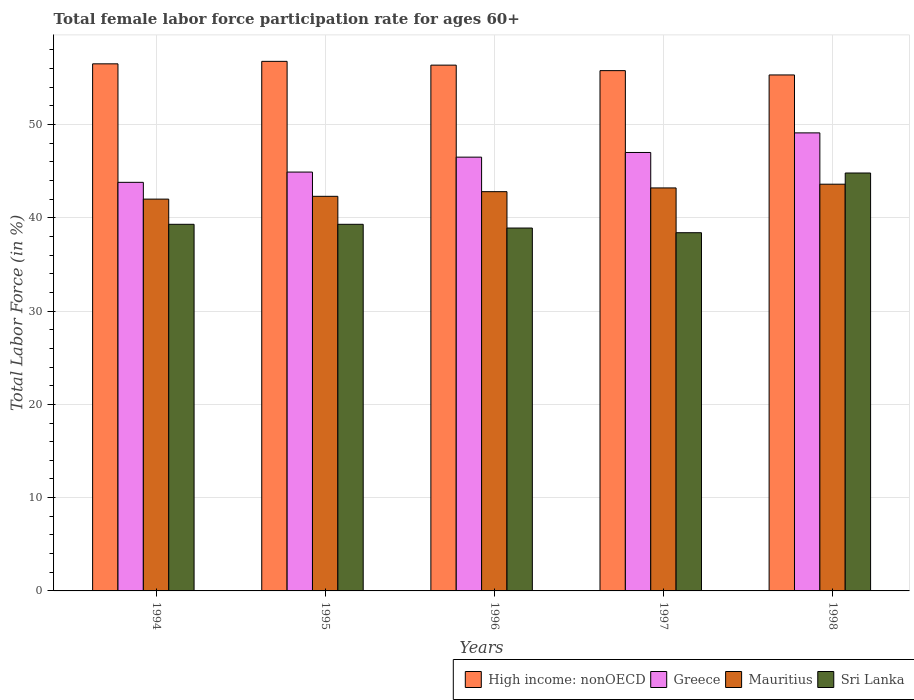How many bars are there on the 5th tick from the right?
Your answer should be compact. 4. In how many cases, is the number of bars for a given year not equal to the number of legend labels?
Keep it short and to the point. 0. What is the female labor force participation rate in Sri Lanka in 1996?
Give a very brief answer. 38.9. Across all years, what is the maximum female labor force participation rate in High income: nonOECD?
Your answer should be compact. 56.77. Across all years, what is the minimum female labor force participation rate in Mauritius?
Give a very brief answer. 42. In which year was the female labor force participation rate in Greece minimum?
Your response must be concise. 1994. What is the total female labor force participation rate in Greece in the graph?
Offer a terse response. 231.3. What is the difference between the female labor force participation rate in Greece in 1996 and that in 1998?
Your response must be concise. -2.6. What is the difference between the female labor force participation rate in Mauritius in 1997 and the female labor force participation rate in Sri Lanka in 1995?
Give a very brief answer. 3.9. What is the average female labor force participation rate in Greece per year?
Give a very brief answer. 46.26. In the year 1997, what is the difference between the female labor force participation rate in Greece and female labor force participation rate in Sri Lanka?
Provide a succinct answer. 8.6. In how many years, is the female labor force participation rate in High income: nonOECD greater than 14 %?
Provide a short and direct response. 5. What is the ratio of the female labor force participation rate in High income: nonOECD in 1995 to that in 1997?
Give a very brief answer. 1.02. Is the difference between the female labor force participation rate in Greece in 1994 and 1995 greater than the difference between the female labor force participation rate in Sri Lanka in 1994 and 1995?
Offer a terse response. No. What is the difference between the highest and the second highest female labor force participation rate in High income: nonOECD?
Your response must be concise. 0.27. What is the difference between the highest and the lowest female labor force participation rate in Mauritius?
Your response must be concise. 1.6. In how many years, is the female labor force participation rate in Mauritius greater than the average female labor force participation rate in Mauritius taken over all years?
Your answer should be very brief. 3. Is the sum of the female labor force participation rate in Greece in 1994 and 1997 greater than the maximum female labor force participation rate in Mauritius across all years?
Offer a terse response. Yes. What does the 3rd bar from the left in 1994 represents?
Offer a very short reply. Mauritius. What does the 1st bar from the right in 1994 represents?
Provide a succinct answer. Sri Lanka. How many bars are there?
Offer a very short reply. 20. Where does the legend appear in the graph?
Your answer should be compact. Bottom right. How many legend labels are there?
Ensure brevity in your answer.  4. How are the legend labels stacked?
Your answer should be compact. Horizontal. What is the title of the graph?
Your answer should be very brief. Total female labor force participation rate for ages 60+. Does "Paraguay" appear as one of the legend labels in the graph?
Keep it short and to the point. No. What is the label or title of the X-axis?
Offer a very short reply. Years. What is the Total Labor Force (in %) in High income: nonOECD in 1994?
Keep it short and to the point. 56.5. What is the Total Labor Force (in %) of Greece in 1994?
Make the answer very short. 43.8. What is the Total Labor Force (in %) of Sri Lanka in 1994?
Your response must be concise. 39.3. What is the Total Labor Force (in %) in High income: nonOECD in 1995?
Provide a short and direct response. 56.77. What is the Total Labor Force (in %) of Greece in 1995?
Offer a very short reply. 44.9. What is the Total Labor Force (in %) of Mauritius in 1995?
Keep it short and to the point. 42.3. What is the Total Labor Force (in %) of Sri Lanka in 1995?
Keep it short and to the point. 39.3. What is the Total Labor Force (in %) in High income: nonOECD in 1996?
Your answer should be very brief. 56.36. What is the Total Labor Force (in %) of Greece in 1996?
Your answer should be very brief. 46.5. What is the Total Labor Force (in %) of Mauritius in 1996?
Your answer should be very brief. 42.8. What is the Total Labor Force (in %) of Sri Lanka in 1996?
Your answer should be very brief. 38.9. What is the Total Labor Force (in %) of High income: nonOECD in 1997?
Your answer should be compact. 55.77. What is the Total Labor Force (in %) in Mauritius in 1997?
Make the answer very short. 43.2. What is the Total Labor Force (in %) in Sri Lanka in 1997?
Provide a succinct answer. 38.4. What is the Total Labor Force (in %) in High income: nonOECD in 1998?
Make the answer very short. 55.31. What is the Total Labor Force (in %) in Greece in 1998?
Keep it short and to the point. 49.1. What is the Total Labor Force (in %) of Mauritius in 1998?
Make the answer very short. 43.6. What is the Total Labor Force (in %) in Sri Lanka in 1998?
Your answer should be compact. 44.8. Across all years, what is the maximum Total Labor Force (in %) in High income: nonOECD?
Offer a very short reply. 56.77. Across all years, what is the maximum Total Labor Force (in %) in Greece?
Your response must be concise. 49.1. Across all years, what is the maximum Total Labor Force (in %) in Mauritius?
Your answer should be very brief. 43.6. Across all years, what is the maximum Total Labor Force (in %) of Sri Lanka?
Your answer should be compact. 44.8. Across all years, what is the minimum Total Labor Force (in %) in High income: nonOECD?
Your answer should be compact. 55.31. Across all years, what is the minimum Total Labor Force (in %) in Greece?
Your response must be concise. 43.8. Across all years, what is the minimum Total Labor Force (in %) in Sri Lanka?
Offer a very short reply. 38.4. What is the total Total Labor Force (in %) of High income: nonOECD in the graph?
Offer a terse response. 280.72. What is the total Total Labor Force (in %) in Greece in the graph?
Keep it short and to the point. 231.3. What is the total Total Labor Force (in %) in Mauritius in the graph?
Your answer should be very brief. 213.9. What is the total Total Labor Force (in %) in Sri Lanka in the graph?
Your answer should be compact. 200.7. What is the difference between the Total Labor Force (in %) in High income: nonOECD in 1994 and that in 1995?
Ensure brevity in your answer.  -0.27. What is the difference between the Total Labor Force (in %) of Mauritius in 1994 and that in 1995?
Keep it short and to the point. -0.3. What is the difference between the Total Labor Force (in %) of Sri Lanka in 1994 and that in 1995?
Make the answer very short. 0. What is the difference between the Total Labor Force (in %) of High income: nonOECD in 1994 and that in 1996?
Your answer should be very brief. 0.14. What is the difference between the Total Labor Force (in %) in Greece in 1994 and that in 1996?
Your answer should be compact. -2.7. What is the difference between the Total Labor Force (in %) of Mauritius in 1994 and that in 1996?
Offer a terse response. -0.8. What is the difference between the Total Labor Force (in %) of High income: nonOECD in 1994 and that in 1997?
Provide a short and direct response. 0.73. What is the difference between the Total Labor Force (in %) in Mauritius in 1994 and that in 1997?
Keep it short and to the point. -1.2. What is the difference between the Total Labor Force (in %) in High income: nonOECD in 1994 and that in 1998?
Your answer should be very brief. 1.19. What is the difference between the Total Labor Force (in %) of Sri Lanka in 1994 and that in 1998?
Provide a succinct answer. -5.5. What is the difference between the Total Labor Force (in %) in High income: nonOECD in 1995 and that in 1996?
Ensure brevity in your answer.  0.4. What is the difference between the Total Labor Force (in %) of Mauritius in 1995 and that in 1996?
Offer a terse response. -0.5. What is the difference between the Total Labor Force (in %) in Sri Lanka in 1995 and that in 1996?
Offer a very short reply. 0.4. What is the difference between the Total Labor Force (in %) in Greece in 1995 and that in 1997?
Your response must be concise. -2.1. What is the difference between the Total Labor Force (in %) in High income: nonOECD in 1995 and that in 1998?
Keep it short and to the point. 1.46. What is the difference between the Total Labor Force (in %) of Mauritius in 1995 and that in 1998?
Keep it short and to the point. -1.3. What is the difference between the Total Labor Force (in %) of Sri Lanka in 1995 and that in 1998?
Keep it short and to the point. -5.5. What is the difference between the Total Labor Force (in %) in High income: nonOECD in 1996 and that in 1997?
Offer a terse response. 0.59. What is the difference between the Total Labor Force (in %) of Mauritius in 1996 and that in 1997?
Provide a short and direct response. -0.4. What is the difference between the Total Labor Force (in %) of High income: nonOECD in 1996 and that in 1998?
Offer a very short reply. 1.05. What is the difference between the Total Labor Force (in %) of Greece in 1996 and that in 1998?
Give a very brief answer. -2.6. What is the difference between the Total Labor Force (in %) in Mauritius in 1996 and that in 1998?
Make the answer very short. -0.8. What is the difference between the Total Labor Force (in %) of Sri Lanka in 1996 and that in 1998?
Your answer should be compact. -5.9. What is the difference between the Total Labor Force (in %) in High income: nonOECD in 1997 and that in 1998?
Offer a terse response. 0.46. What is the difference between the Total Labor Force (in %) of High income: nonOECD in 1994 and the Total Labor Force (in %) of Greece in 1995?
Ensure brevity in your answer.  11.6. What is the difference between the Total Labor Force (in %) in High income: nonOECD in 1994 and the Total Labor Force (in %) in Mauritius in 1995?
Offer a very short reply. 14.2. What is the difference between the Total Labor Force (in %) of High income: nonOECD in 1994 and the Total Labor Force (in %) of Sri Lanka in 1995?
Your answer should be very brief. 17.2. What is the difference between the Total Labor Force (in %) of Greece in 1994 and the Total Labor Force (in %) of Sri Lanka in 1995?
Ensure brevity in your answer.  4.5. What is the difference between the Total Labor Force (in %) of Mauritius in 1994 and the Total Labor Force (in %) of Sri Lanka in 1995?
Your answer should be very brief. 2.7. What is the difference between the Total Labor Force (in %) of High income: nonOECD in 1994 and the Total Labor Force (in %) of Greece in 1996?
Provide a succinct answer. 10. What is the difference between the Total Labor Force (in %) in High income: nonOECD in 1994 and the Total Labor Force (in %) in Mauritius in 1996?
Your answer should be compact. 13.7. What is the difference between the Total Labor Force (in %) of High income: nonOECD in 1994 and the Total Labor Force (in %) of Sri Lanka in 1996?
Provide a succinct answer. 17.6. What is the difference between the Total Labor Force (in %) of Greece in 1994 and the Total Labor Force (in %) of Mauritius in 1996?
Your answer should be compact. 1. What is the difference between the Total Labor Force (in %) in High income: nonOECD in 1994 and the Total Labor Force (in %) in Greece in 1997?
Ensure brevity in your answer.  9.5. What is the difference between the Total Labor Force (in %) in High income: nonOECD in 1994 and the Total Labor Force (in %) in Mauritius in 1997?
Give a very brief answer. 13.3. What is the difference between the Total Labor Force (in %) in High income: nonOECD in 1994 and the Total Labor Force (in %) in Sri Lanka in 1997?
Offer a very short reply. 18.1. What is the difference between the Total Labor Force (in %) of Greece in 1994 and the Total Labor Force (in %) of Mauritius in 1997?
Your answer should be very brief. 0.6. What is the difference between the Total Labor Force (in %) in Greece in 1994 and the Total Labor Force (in %) in Sri Lanka in 1997?
Make the answer very short. 5.4. What is the difference between the Total Labor Force (in %) of Mauritius in 1994 and the Total Labor Force (in %) of Sri Lanka in 1997?
Your answer should be compact. 3.6. What is the difference between the Total Labor Force (in %) of High income: nonOECD in 1994 and the Total Labor Force (in %) of Greece in 1998?
Provide a short and direct response. 7.4. What is the difference between the Total Labor Force (in %) of High income: nonOECD in 1994 and the Total Labor Force (in %) of Mauritius in 1998?
Ensure brevity in your answer.  12.9. What is the difference between the Total Labor Force (in %) of High income: nonOECD in 1994 and the Total Labor Force (in %) of Sri Lanka in 1998?
Provide a short and direct response. 11.7. What is the difference between the Total Labor Force (in %) of Greece in 1994 and the Total Labor Force (in %) of Mauritius in 1998?
Ensure brevity in your answer.  0.2. What is the difference between the Total Labor Force (in %) of Mauritius in 1994 and the Total Labor Force (in %) of Sri Lanka in 1998?
Make the answer very short. -2.8. What is the difference between the Total Labor Force (in %) of High income: nonOECD in 1995 and the Total Labor Force (in %) of Greece in 1996?
Your answer should be very brief. 10.27. What is the difference between the Total Labor Force (in %) of High income: nonOECD in 1995 and the Total Labor Force (in %) of Mauritius in 1996?
Provide a short and direct response. 13.97. What is the difference between the Total Labor Force (in %) of High income: nonOECD in 1995 and the Total Labor Force (in %) of Sri Lanka in 1996?
Provide a succinct answer. 17.87. What is the difference between the Total Labor Force (in %) in Mauritius in 1995 and the Total Labor Force (in %) in Sri Lanka in 1996?
Your response must be concise. 3.4. What is the difference between the Total Labor Force (in %) in High income: nonOECD in 1995 and the Total Labor Force (in %) in Greece in 1997?
Make the answer very short. 9.77. What is the difference between the Total Labor Force (in %) of High income: nonOECD in 1995 and the Total Labor Force (in %) of Mauritius in 1997?
Keep it short and to the point. 13.57. What is the difference between the Total Labor Force (in %) in High income: nonOECD in 1995 and the Total Labor Force (in %) in Sri Lanka in 1997?
Keep it short and to the point. 18.37. What is the difference between the Total Labor Force (in %) in Greece in 1995 and the Total Labor Force (in %) in Sri Lanka in 1997?
Offer a terse response. 6.5. What is the difference between the Total Labor Force (in %) in Mauritius in 1995 and the Total Labor Force (in %) in Sri Lanka in 1997?
Ensure brevity in your answer.  3.9. What is the difference between the Total Labor Force (in %) of High income: nonOECD in 1995 and the Total Labor Force (in %) of Greece in 1998?
Keep it short and to the point. 7.67. What is the difference between the Total Labor Force (in %) of High income: nonOECD in 1995 and the Total Labor Force (in %) of Mauritius in 1998?
Provide a succinct answer. 13.17. What is the difference between the Total Labor Force (in %) in High income: nonOECD in 1995 and the Total Labor Force (in %) in Sri Lanka in 1998?
Keep it short and to the point. 11.97. What is the difference between the Total Labor Force (in %) of Mauritius in 1995 and the Total Labor Force (in %) of Sri Lanka in 1998?
Ensure brevity in your answer.  -2.5. What is the difference between the Total Labor Force (in %) in High income: nonOECD in 1996 and the Total Labor Force (in %) in Greece in 1997?
Offer a very short reply. 9.36. What is the difference between the Total Labor Force (in %) of High income: nonOECD in 1996 and the Total Labor Force (in %) of Mauritius in 1997?
Give a very brief answer. 13.16. What is the difference between the Total Labor Force (in %) of High income: nonOECD in 1996 and the Total Labor Force (in %) of Sri Lanka in 1997?
Give a very brief answer. 17.96. What is the difference between the Total Labor Force (in %) of Mauritius in 1996 and the Total Labor Force (in %) of Sri Lanka in 1997?
Make the answer very short. 4.4. What is the difference between the Total Labor Force (in %) in High income: nonOECD in 1996 and the Total Labor Force (in %) in Greece in 1998?
Give a very brief answer. 7.26. What is the difference between the Total Labor Force (in %) of High income: nonOECD in 1996 and the Total Labor Force (in %) of Mauritius in 1998?
Your answer should be compact. 12.76. What is the difference between the Total Labor Force (in %) of High income: nonOECD in 1996 and the Total Labor Force (in %) of Sri Lanka in 1998?
Keep it short and to the point. 11.56. What is the difference between the Total Labor Force (in %) in Greece in 1996 and the Total Labor Force (in %) in Sri Lanka in 1998?
Keep it short and to the point. 1.7. What is the difference between the Total Labor Force (in %) of Mauritius in 1996 and the Total Labor Force (in %) of Sri Lanka in 1998?
Offer a terse response. -2. What is the difference between the Total Labor Force (in %) of High income: nonOECD in 1997 and the Total Labor Force (in %) of Greece in 1998?
Offer a very short reply. 6.67. What is the difference between the Total Labor Force (in %) of High income: nonOECD in 1997 and the Total Labor Force (in %) of Mauritius in 1998?
Make the answer very short. 12.17. What is the difference between the Total Labor Force (in %) in High income: nonOECD in 1997 and the Total Labor Force (in %) in Sri Lanka in 1998?
Offer a terse response. 10.97. What is the difference between the Total Labor Force (in %) in Greece in 1997 and the Total Labor Force (in %) in Mauritius in 1998?
Provide a succinct answer. 3.4. What is the average Total Labor Force (in %) of High income: nonOECD per year?
Your answer should be very brief. 56.14. What is the average Total Labor Force (in %) of Greece per year?
Your response must be concise. 46.26. What is the average Total Labor Force (in %) in Mauritius per year?
Give a very brief answer. 42.78. What is the average Total Labor Force (in %) in Sri Lanka per year?
Your response must be concise. 40.14. In the year 1994, what is the difference between the Total Labor Force (in %) of High income: nonOECD and Total Labor Force (in %) of Greece?
Your response must be concise. 12.7. In the year 1994, what is the difference between the Total Labor Force (in %) of High income: nonOECD and Total Labor Force (in %) of Mauritius?
Ensure brevity in your answer.  14.5. In the year 1994, what is the difference between the Total Labor Force (in %) in High income: nonOECD and Total Labor Force (in %) in Sri Lanka?
Provide a short and direct response. 17.2. In the year 1994, what is the difference between the Total Labor Force (in %) in Greece and Total Labor Force (in %) in Mauritius?
Provide a succinct answer. 1.8. In the year 1994, what is the difference between the Total Labor Force (in %) in Greece and Total Labor Force (in %) in Sri Lanka?
Your answer should be compact. 4.5. In the year 1994, what is the difference between the Total Labor Force (in %) in Mauritius and Total Labor Force (in %) in Sri Lanka?
Ensure brevity in your answer.  2.7. In the year 1995, what is the difference between the Total Labor Force (in %) in High income: nonOECD and Total Labor Force (in %) in Greece?
Offer a very short reply. 11.87. In the year 1995, what is the difference between the Total Labor Force (in %) of High income: nonOECD and Total Labor Force (in %) of Mauritius?
Offer a very short reply. 14.47. In the year 1995, what is the difference between the Total Labor Force (in %) of High income: nonOECD and Total Labor Force (in %) of Sri Lanka?
Your answer should be very brief. 17.47. In the year 1995, what is the difference between the Total Labor Force (in %) in Greece and Total Labor Force (in %) in Sri Lanka?
Offer a terse response. 5.6. In the year 1996, what is the difference between the Total Labor Force (in %) of High income: nonOECD and Total Labor Force (in %) of Greece?
Give a very brief answer. 9.86. In the year 1996, what is the difference between the Total Labor Force (in %) in High income: nonOECD and Total Labor Force (in %) in Mauritius?
Provide a succinct answer. 13.56. In the year 1996, what is the difference between the Total Labor Force (in %) in High income: nonOECD and Total Labor Force (in %) in Sri Lanka?
Make the answer very short. 17.46. In the year 1997, what is the difference between the Total Labor Force (in %) in High income: nonOECD and Total Labor Force (in %) in Greece?
Provide a short and direct response. 8.77. In the year 1997, what is the difference between the Total Labor Force (in %) of High income: nonOECD and Total Labor Force (in %) of Mauritius?
Ensure brevity in your answer.  12.57. In the year 1997, what is the difference between the Total Labor Force (in %) in High income: nonOECD and Total Labor Force (in %) in Sri Lanka?
Keep it short and to the point. 17.37. In the year 1997, what is the difference between the Total Labor Force (in %) in Mauritius and Total Labor Force (in %) in Sri Lanka?
Provide a succinct answer. 4.8. In the year 1998, what is the difference between the Total Labor Force (in %) in High income: nonOECD and Total Labor Force (in %) in Greece?
Your answer should be very brief. 6.21. In the year 1998, what is the difference between the Total Labor Force (in %) in High income: nonOECD and Total Labor Force (in %) in Mauritius?
Provide a succinct answer. 11.71. In the year 1998, what is the difference between the Total Labor Force (in %) of High income: nonOECD and Total Labor Force (in %) of Sri Lanka?
Your response must be concise. 10.51. What is the ratio of the Total Labor Force (in %) of High income: nonOECD in 1994 to that in 1995?
Offer a terse response. 1. What is the ratio of the Total Labor Force (in %) of Greece in 1994 to that in 1995?
Your answer should be very brief. 0.98. What is the ratio of the Total Labor Force (in %) of Mauritius in 1994 to that in 1995?
Provide a short and direct response. 0.99. What is the ratio of the Total Labor Force (in %) of Greece in 1994 to that in 1996?
Offer a very short reply. 0.94. What is the ratio of the Total Labor Force (in %) in Mauritius in 1994 to that in 1996?
Make the answer very short. 0.98. What is the ratio of the Total Labor Force (in %) of Sri Lanka in 1994 to that in 1996?
Make the answer very short. 1.01. What is the ratio of the Total Labor Force (in %) in High income: nonOECD in 1994 to that in 1997?
Provide a short and direct response. 1.01. What is the ratio of the Total Labor Force (in %) of Greece in 1994 to that in 1997?
Make the answer very short. 0.93. What is the ratio of the Total Labor Force (in %) in Mauritius in 1994 to that in 1997?
Offer a terse response. 0.97. What is the ratio of the Total Labor Force (in %) of Sri Lanka in 1994 to that in 1997?
Make the answer very short. 1.02. What is the ratio of the Total Labor Force (in %) of High income: nonOECD in 1994 to that in 1998?
Your answer should be very brief. 1.02. What is the ratio of the Total Labor Force (in %) in Greece in 1994 to that in 1998?
Ensure brevity in your answer.  0.89. What is the ratio of the Total Labor Force (in %) in Mauritius in 1994 to that in 1998?
Keep it short and to the point. 0.96. What is the ratio of the Total Labor Force (in %) in Sri Lanka in 1994 to that in 1998?
Your answer should be compact. 0.88. What is the ratio of the Total Labor Force (in %) in Greece in 1995 to that in 1996?
Your response must be concise. 0.97. What is the ratio of the Total Labor Force (in %) of Mauritius in 1995 to that in 1996?
Ensure brevity in your answer.  0.99. What is the ratio of the Total Labor Force (in %) in Sri Lanka in 1995 to that in 1996?
Your response must be concise. 1.01. What is the ratio of the Total Labor Force (in %) in High income: nonOECD in 1995 to that in 1997?
Keep it short and to the point. 1.02. What is the ratio of the Total Labor Force (in %) in Greece in 1995 to that in 1997?
Keep it short and to the point. 0.96. What is the ratio of the Total Labor Force (in %) in Mauritius in 1995 to that in 1997?
Your answer should be very brief. 0.98. What is the ratio of the Total Labor Force (in %) of Sri Lanka in 1995 to that in 1997?
Give a very brief answer. 1.02. What is the ratio of the Total Labor Force (in %) in High income: nonOECD in 1995 to that in 1998?
Keep it short and to the point. 1.03. What is the ratio of the Total Labor Force (in %) of Greece in 1995 to that in 1998?
Keep it short and to the point. 0.91. What is the ratio of the Total Labor Force (in %) of Mauritius in 1995 to that in 1998?
Offer a terse response. 0.97. What is the ratio of the Total Labor Force (in %) in Sri Lanka in 1995 to that in 1998?
Your answer should be compact. 0.88. What is the ratio of the Total Labor Force (in %) in High income: nonOECD in 1996 to that in 1997?
Your response must be concise. 1.01. What is the ratio of the Total Labor Force (in %) of Sri Lanka in 1996 to that in 1997?
Provide a succinct answer. 1.01. What is the ratio of the Total Labor Force (in %) of High income: nonOECD in 1996 to that in 1998?
Keep it short and to the point. 1.02. What is the ratio of the Total Labor Force (in %) in Greece in 1996 to that in 1998?
Your answer should be compact. 0.95. What is the ratio of the Total Labor Force (in %) in Mauritius in 1996 to that in 1998?
Your answer should be very brief. 0.98. What is the ratio of the Total Labor Force (in %) of Sri Lanka in 1996 to that in 1998?
Your response must be concise. 0.87. What is the ratio of the Total Labor Force (in %) in High income: nonOECD in 1997 to that in 1998?
Your answer should be compact. 1.01. What is the ratio of the Total Labor Force (in %) in Greece in 1997 to that in 1998?
Your response must be concise. 0.96. What is the difference between the highest and the second highest Total Labor Force (in %) of High income: nonOECD?
Your answer should be very brief. 0.27. What is the difference between the highest and the second highest Total Labor Force (in %) in Greece?
Ensure brevity in your answer.  2.1. What is the difference between the highest and the second highest Total Labor Force (in %) of Sri Lanka?
Ensure brevity in your answer.  5.5. What is the difference between the highest and the lowest Total Labor Force (in %) in High income: nonOECD?
Ensure brevity in your answer.  1.46. 